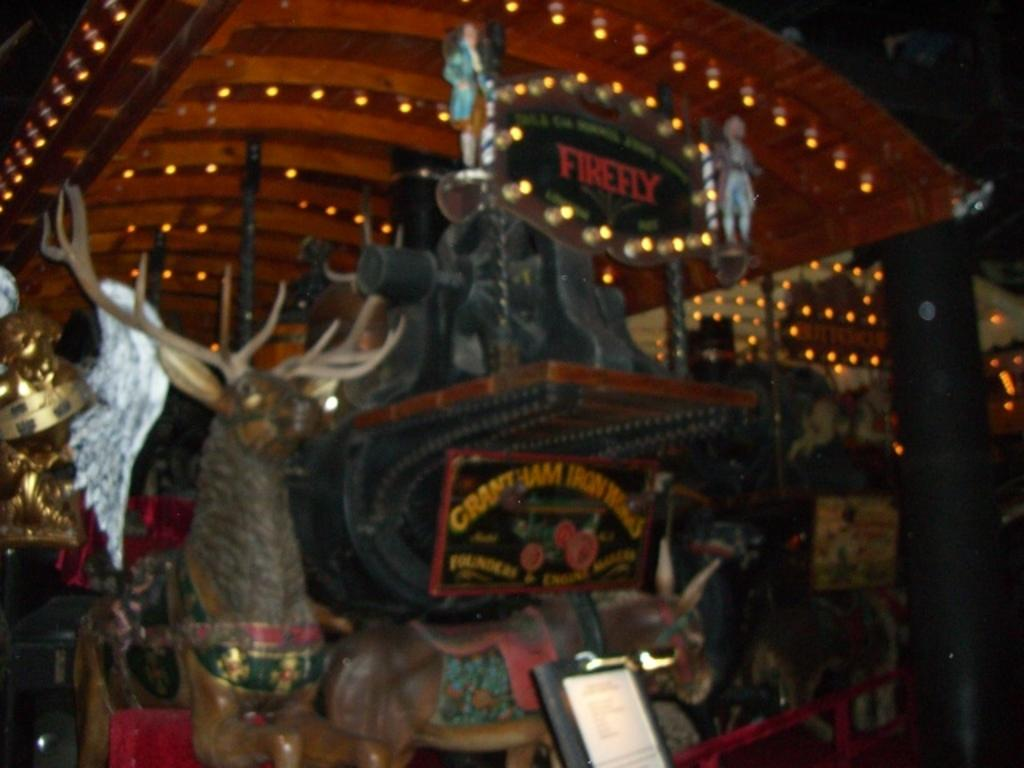What objects are placed on the black color object in the image? There are toy dolls and frames on the black color object in the image. What is the color of the object that the toy dolls and frames are placed on? The object is black in color. What can be seen in the background of the image? There is a brown color shade and lights visible in the background. What type of statement can be seen written on the toy dolls in the image? There are no statements written on the toy dolls in the image; they are simply dolls placed on a black object. 